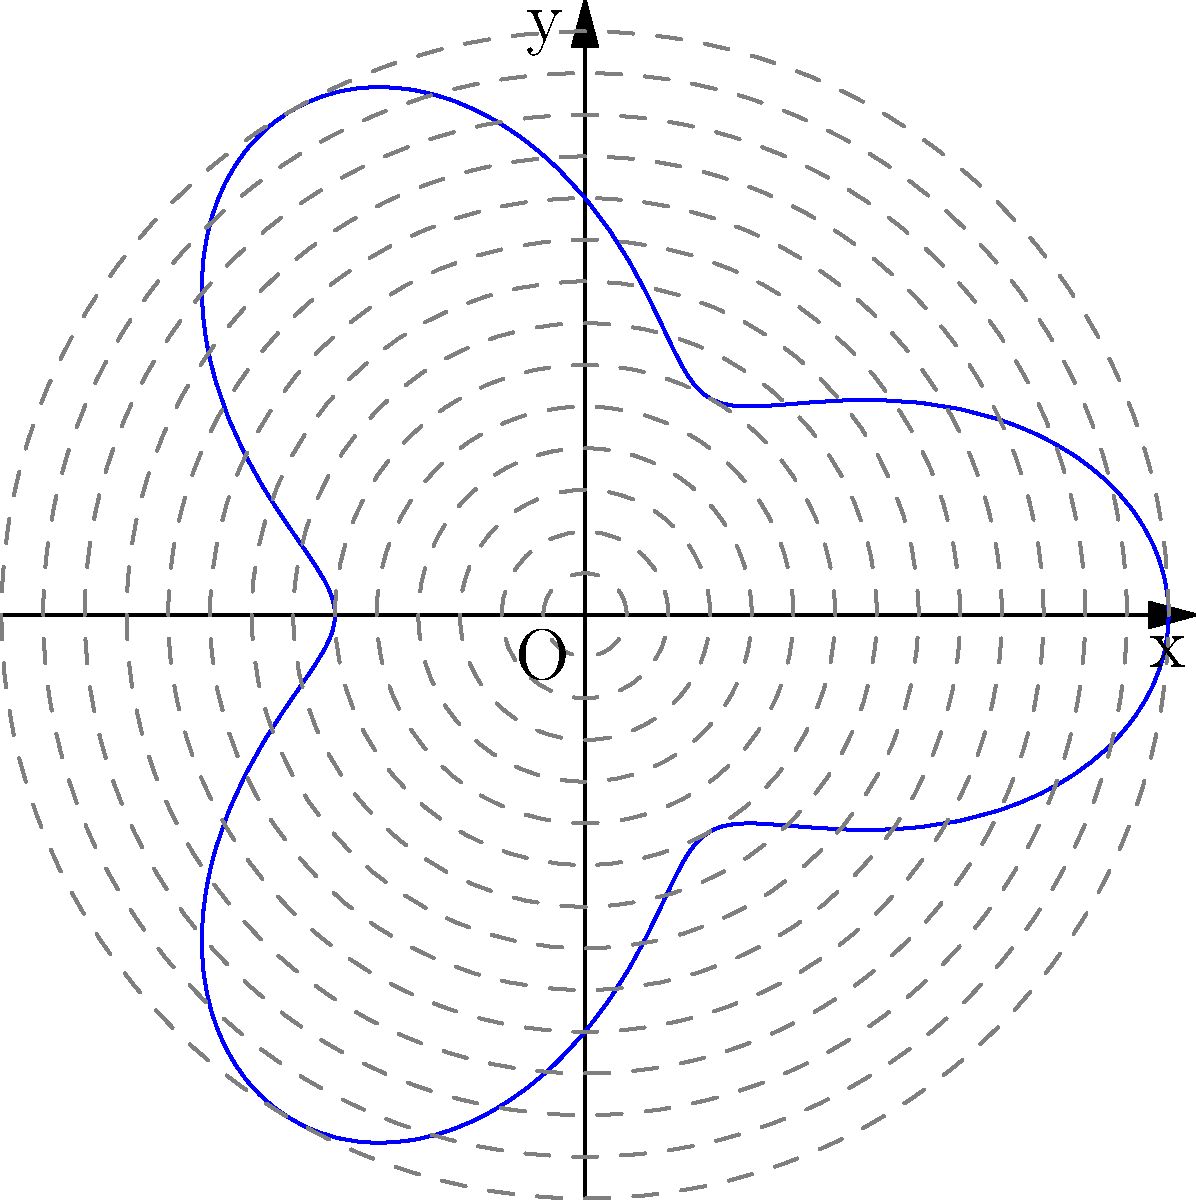A reconnaissance aircraft is flying a patrol route described by the polar equation $r = 5 + 2\cos(3\theta)$, where $r$ is in nautical miles. What is the maximum distance the aircraft reaches from the origin during its flight path? To find the maximum distance the aircraft reaches from the origin, we need to analyze the given polar equation:

1) The equation is $r = 5 + 2\cos(3\theta)$

2) The constant term 5 represents the average distance from the origin.

3) The cosine term $2\cos(3\theta)$ represents the variation around this average.

4) The amplitude of the cosine function is 2, which means the distance oscillates 2 units above and below the average.

5) Therefore, the maximum distance will occur when $\cos(3\theta) = 1$ (its maximum value).

6) At this point, the equation becomes:
   $r_{max} = 5 + 2(1) = 5 + 2 = 7$

7) Thus, the maximum distance the aircraft reaches from the origin is 7 nautical miles.
Answer: 7 nautical miles 